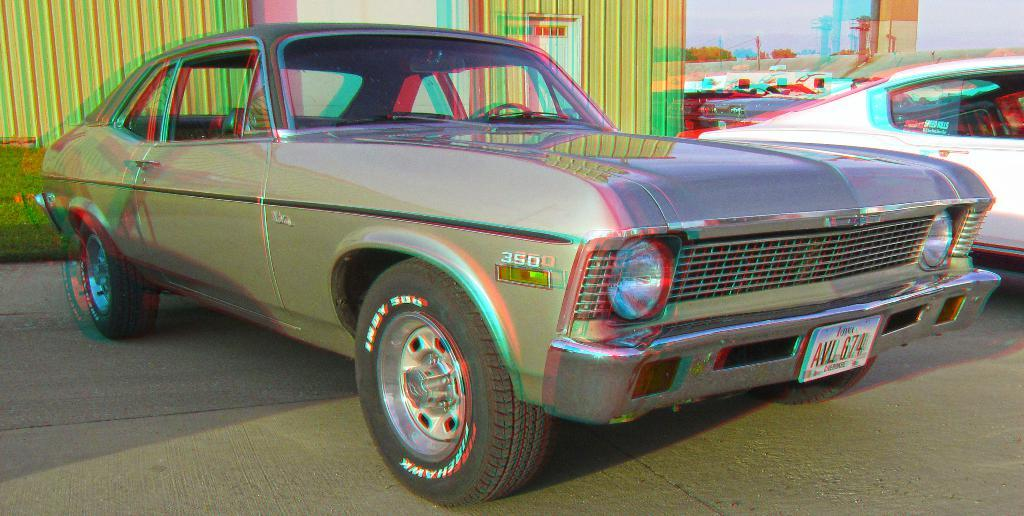What is visible on the ground in the image? The ground is visible in the image, and there are cars on the ground. What type of vegetation can be seen in the image? There is grass in the image, as well as trees. What structures are present in the image? There are buildings in the image. What part of the natural environment is visible in the image? The sky is visible in the background of the image. What type of insurance is being sold by the trees in the image? There is no indication in the image that the trees are selling insurance, and therefore no such activity can be observed. Can you tell me how the sun is turning in the image? The sun is not visible in the image, and even if it were, it does not turn; it rises and sets. 